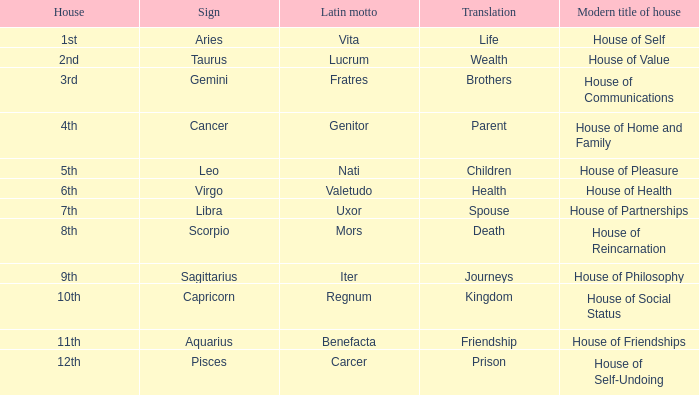Which astrological sign has the Latin motto of Vita? Aries. 